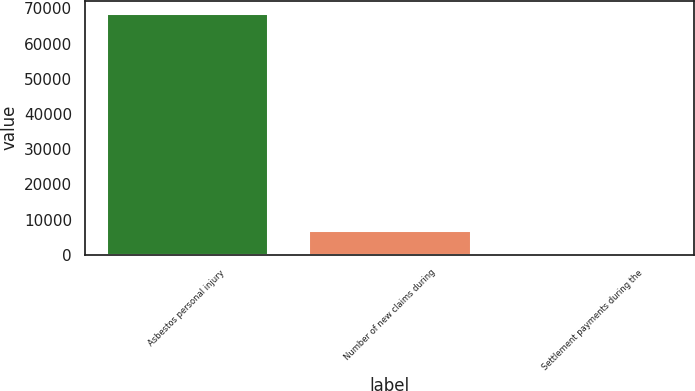Convert chart. <chart><loc_0><loc_0><loc_500><loc_500><bar_chart><fcel>Asbestos personal injury<fcel>Number of new claims during<fcel>Settlement payments during the<nl><fcel>68804<fcel>6914.24<fcel>37.6<nl></chart> 